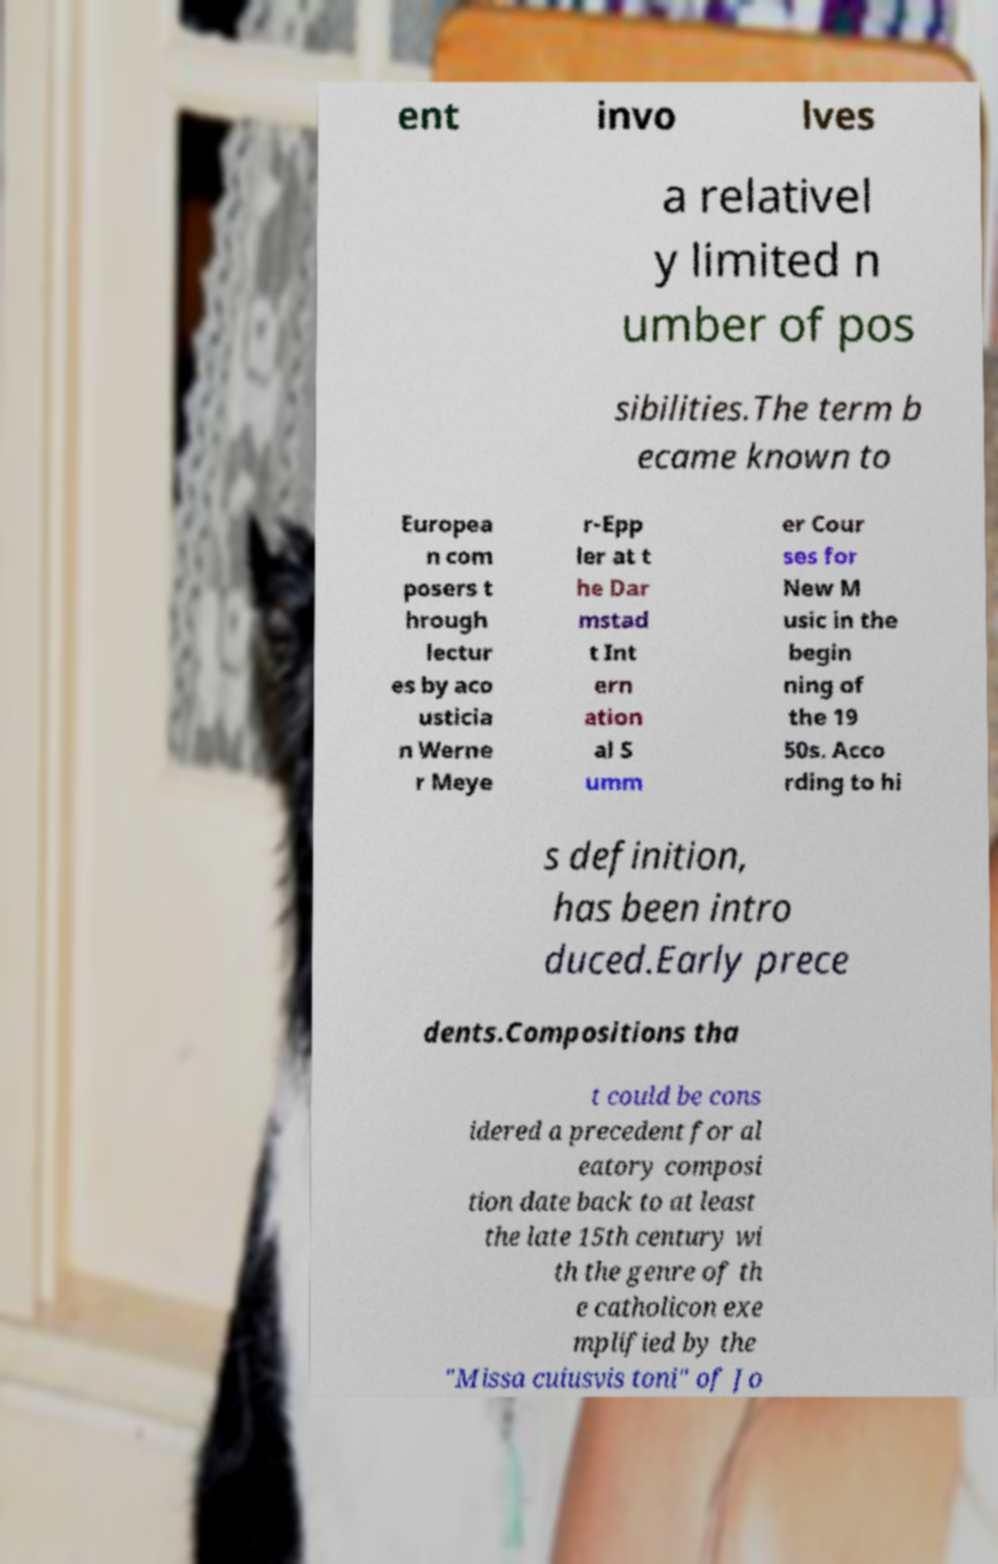Can you read and provide the text displayed in the image?This photo seems to have some interesting text. Can you extract and type it out for me? ent invo lves a relativel y limited n umber of pos sibilities.The term b ecame known to Europea n com posers t hrough lectur es by aco usticia n Werne r Meye r-Epp ler at t he Dar mstad t Int ern ation al S umm er Cour ses for New M usic in the begin ning of the 19 50s. Acco rding to hi s definition, has been intro duced.Early prece dents.Compositions tha t could be cons idered a precedent for al eatory composi tion date back to at least the late 15th century wi th the genre of th e catholicon exe mplified by the "Missa cuiusvis toni" of Jo 